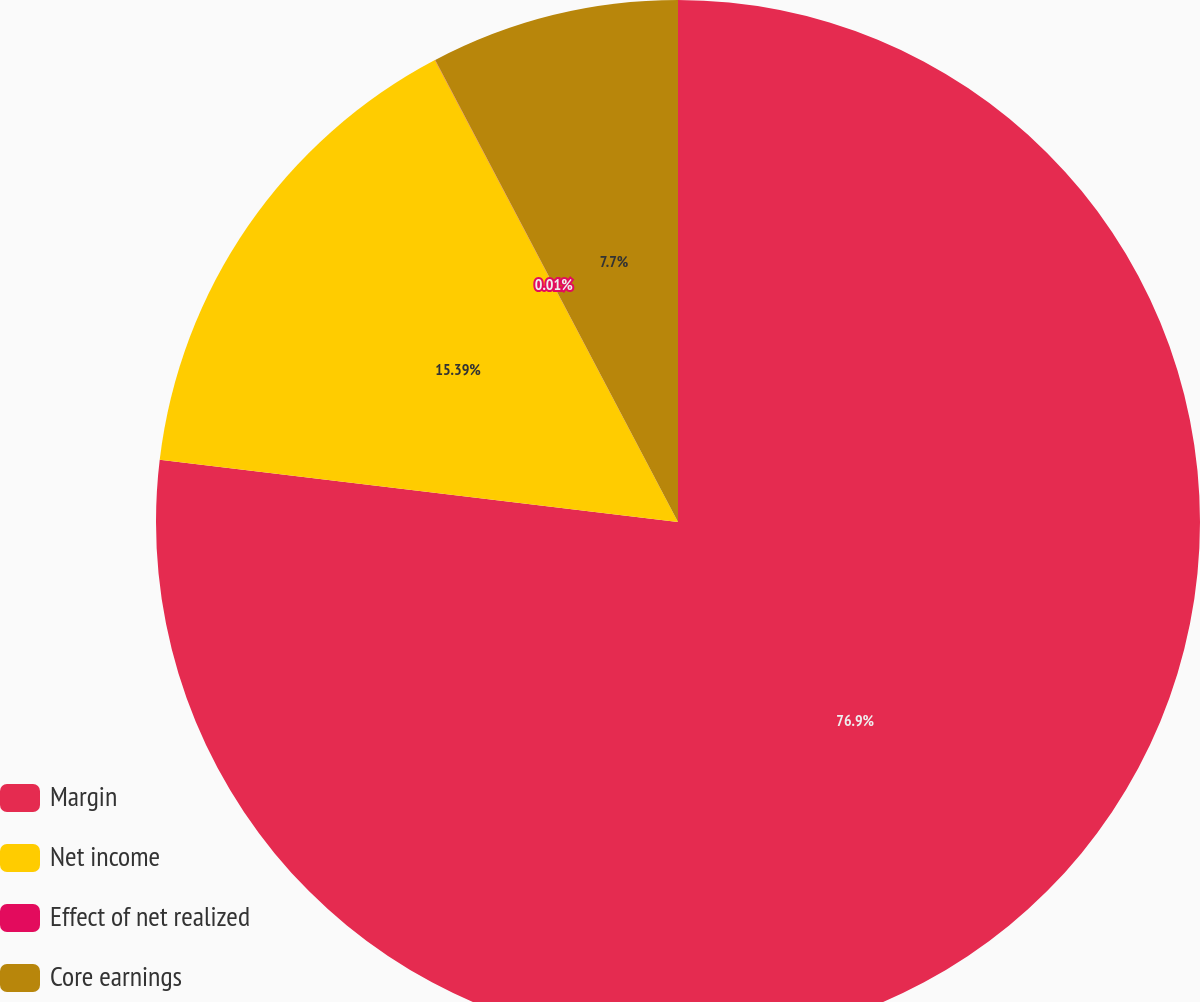<chart> <loc_0><loc_0><loc_500><loc_500><pie_chart><fcel>Margin<fcel>Net income<fcel>Effect of net realized<fcel>Core earnings<nl><fcel>76.9%<fcel>15.39%<fcel>0.01%<fcel>7.7%<nl></chart> 